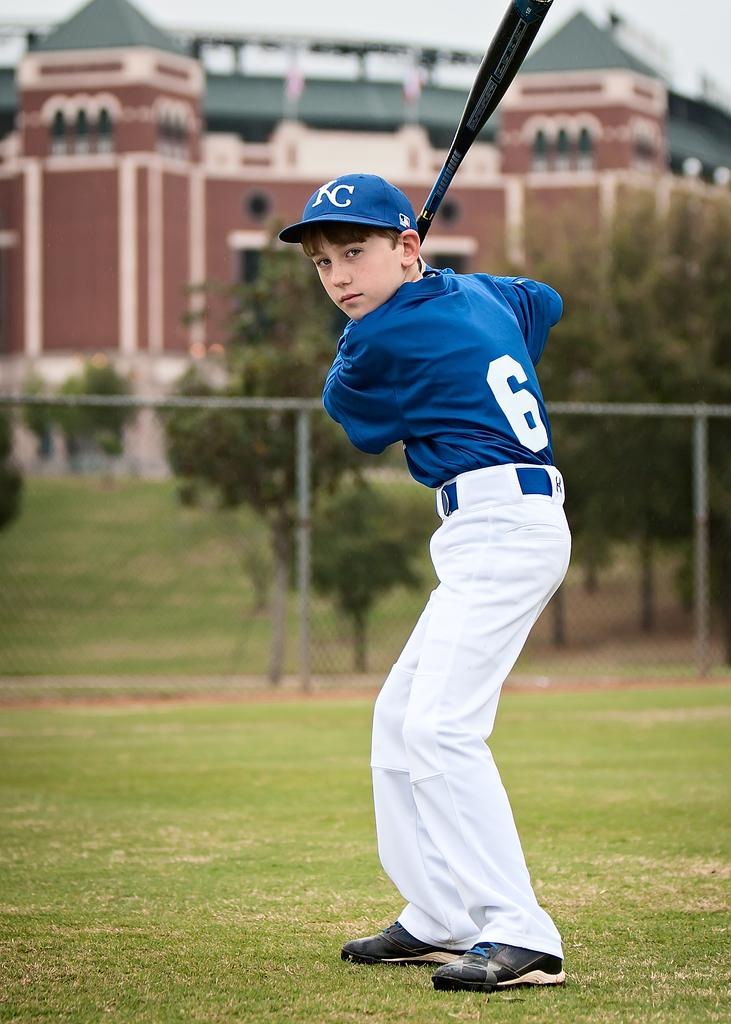<image>
Provide a brief description of the given image. A young boy in baseball uniform that says 6 on the back 